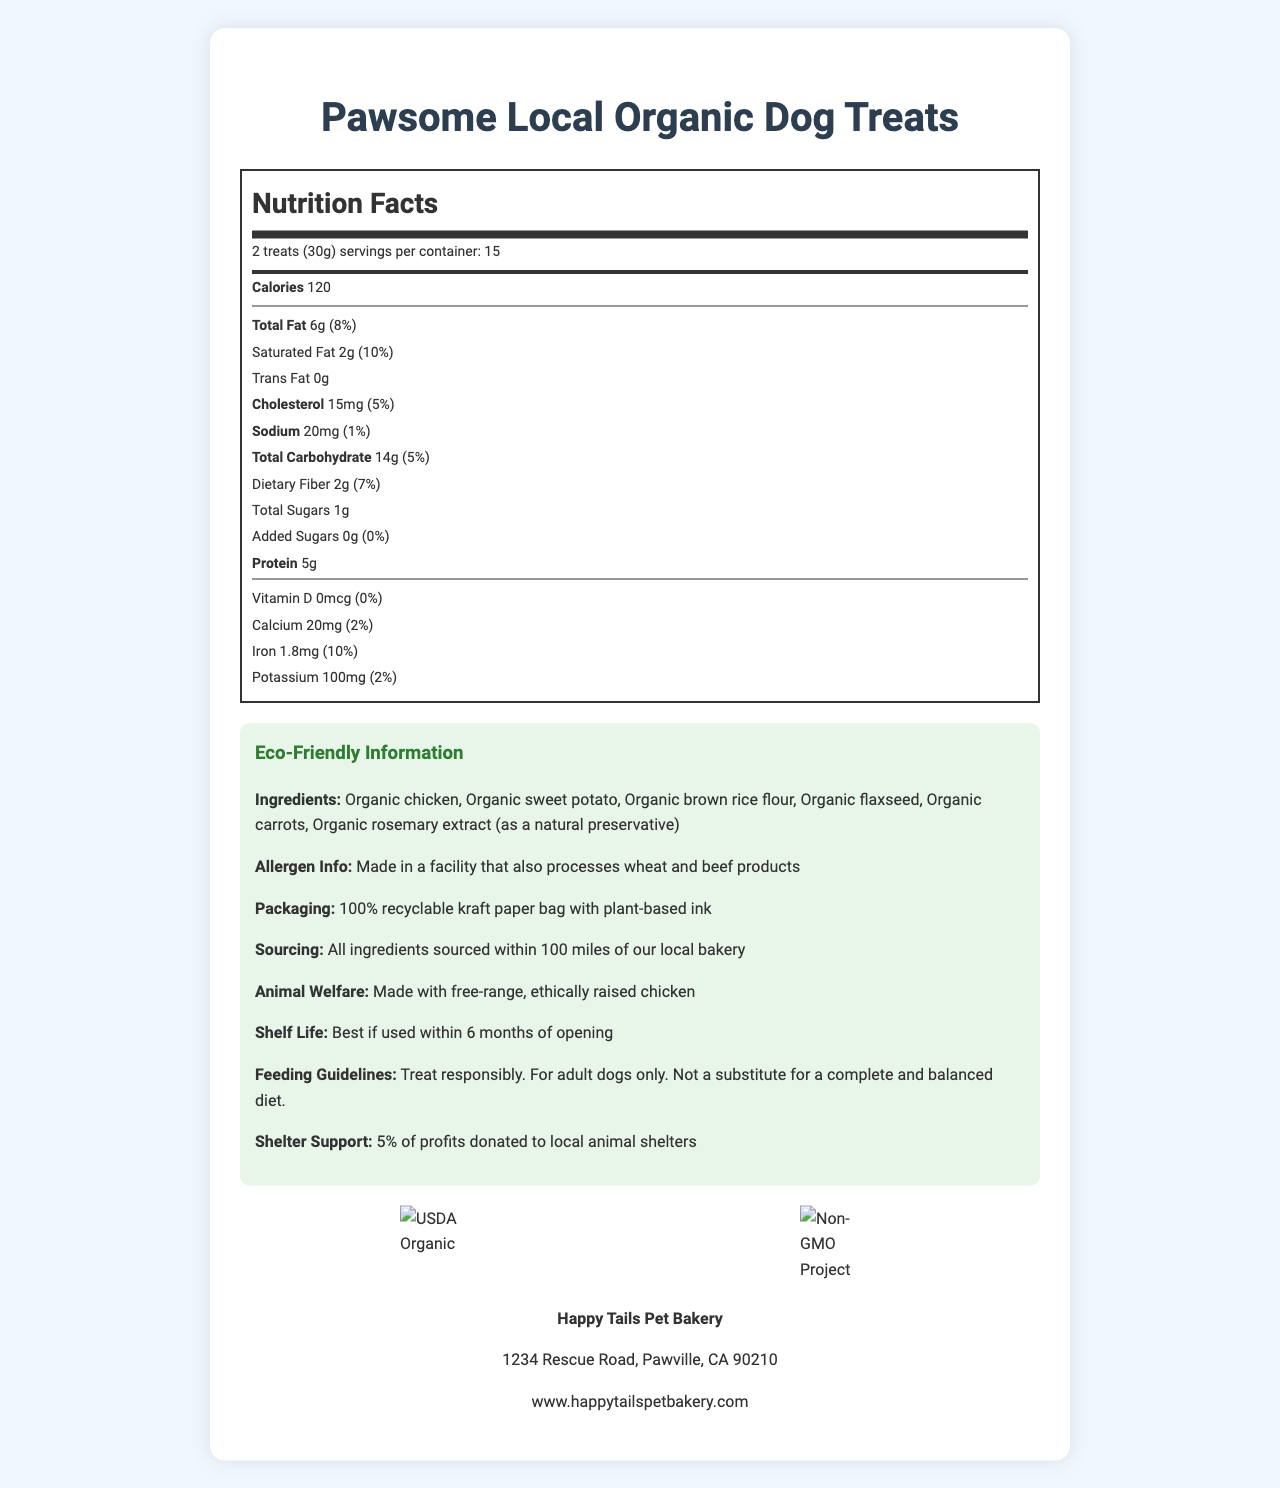what is the serving size for Pawsome Local Organic Dog Treats? The serving size is mentioned right at the beginning beneath the product name.
Answer: 2 treats (30g) how many calories are in one serving of these dog treats? The calorie count is listed within the Nutrition Facts section.
Answer: 120 what is the total amount of fat per serving? The amount of total fat is specified in the Nutrition Facts.
Answer: 6g how much dietary fiber does one serving contain? Dietary fiber content is mentioned under the Total Carbohydrate section in the Nutrition Facts.
Answer: 2g which ingredient acts as a natural preservative in these dog treats? The document lists Organic rosemary extract as a natural preservative in the ingredients section.
Answer: Organic rosemary extract which certification does this product have? A. FDA Approved B. USDA Organic C. Fair Trade Certified The document includes an image of the USDA Organic certification and explicitly mentions it under certifications.
Answer: B. USDA Organic what is the daily value of saturated fat for these dog treats? i. 5% ii. 10% iii. 8% The saturated fat daily value is mentioned as 10% in the Nutrition Facts.
Answer: ii. 10% do these dog treats contain any added sugars? The added sugars section mentions 0g and 0% daily value.
Answer: No is the packaging of these dog treats recyclable? The document states that the packaging is a 100% recyclable kraft paper bag.
Answer: Yes should these dog treats be used as a complete and balanced diet? The feeding guidelines specify that the treats are not a substitute for a complete and balanced diet.
Answer: No describe the main idea of the document. This document outlines the nutritional facts, certifications, packaging, sourcing, and other relevant information about organic, locally-sourced dog treats.
Answer: Summary of the document: The Pawsome Local Organic Dog Treats are healthy, locally-sourced, and eco-friendly dog treats made by Happy Tails Pet Bakery. They are USDA Organic and Non-GMO Project Verified, containing nutritious ingredients with detailed nutritional facts provided. The packaging is recyclable, and the company supports animal shelters. The treats are not a substitute for a complete diet and should be fed responsibly to adult dogs. how much potassium is in a serving of these dog treats? The amount of potassium is listed in the Nutrition Facts section.
Answer: 100mg what is the name of the company that makes these dog treats? The company name is listed at the end of the document along with its location and website.
Answer: Happy Tails Pet Bakery what is the shelf life of these dog treats? The shelf life is mentioned in the Eco-Friendly Information section.
Answer: Best if used within 6 months of opening where are all the ingredients sourced from? The sourcing information specifies that all ingredients are sourced within this range.
Answer: Within 100 miles of the local bakery what is the daily value of iron in a serving? The daily value of iron is provided in the Nutrition Facts.
Answer: 10% can this document tell us the exact price of the dog treats? The document does not provide any information regarding the price of the dog treats.
Answer: Not enough information 